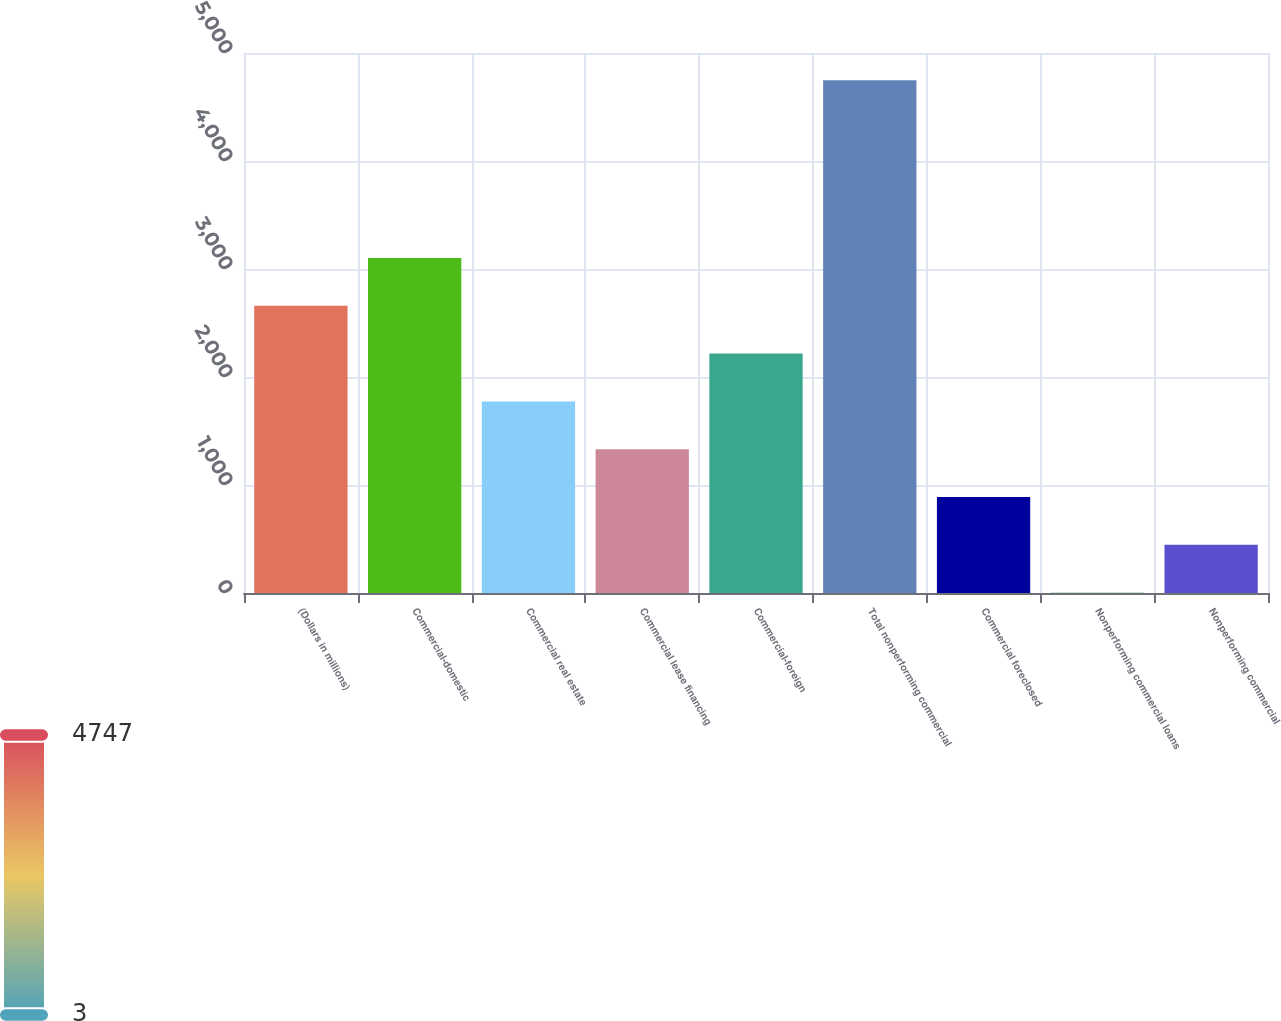Convert chart. <chart><loc_0><loc_0><loc_500><loc_500><bar_chart><fcel>(Dollars in millions)<fcel>Commercial-domestic<fcel>Commercial real estate<fcel>Commercial lease financing<fcel>Commercial-foreign<fcel>Total nonperforming commercial<fcel>Commercial foreclosed<fcel>Nonperforming commercial loans<fcel>Nonperforming commercial<nl><fcel>2659.16<fcel>3101.86<fcel>1773.76<fcel>1331.06<fcel>2216.46<fcel>4746.7<fcel>888.36<fcel>2.96<fcel>445.66<nl></chart> 